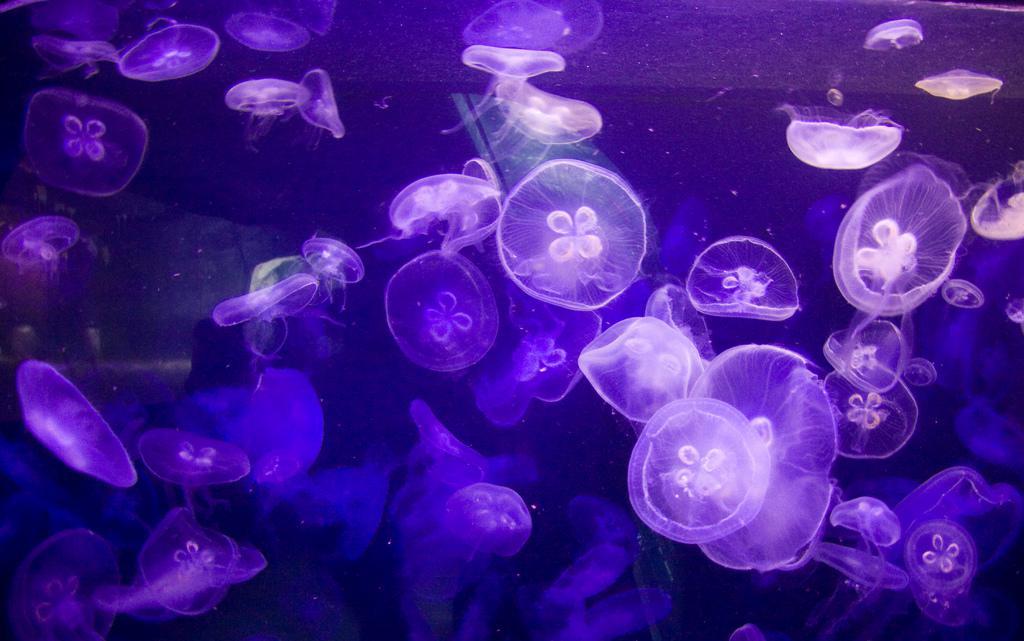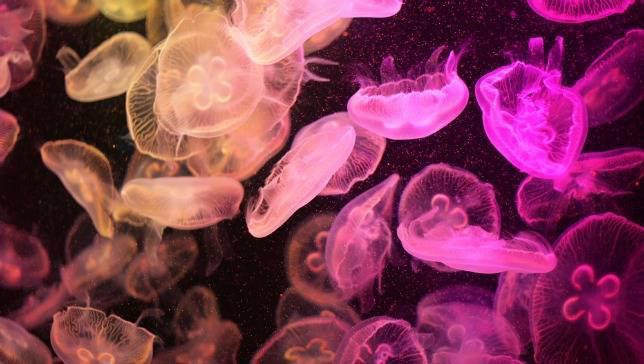The first image is the image on the left, the second image is the image on the right. Assess this claim about the two images: "The pink jellyfish in the image on the left is against a black background.". Correct or not? Answer yes or no. No. 